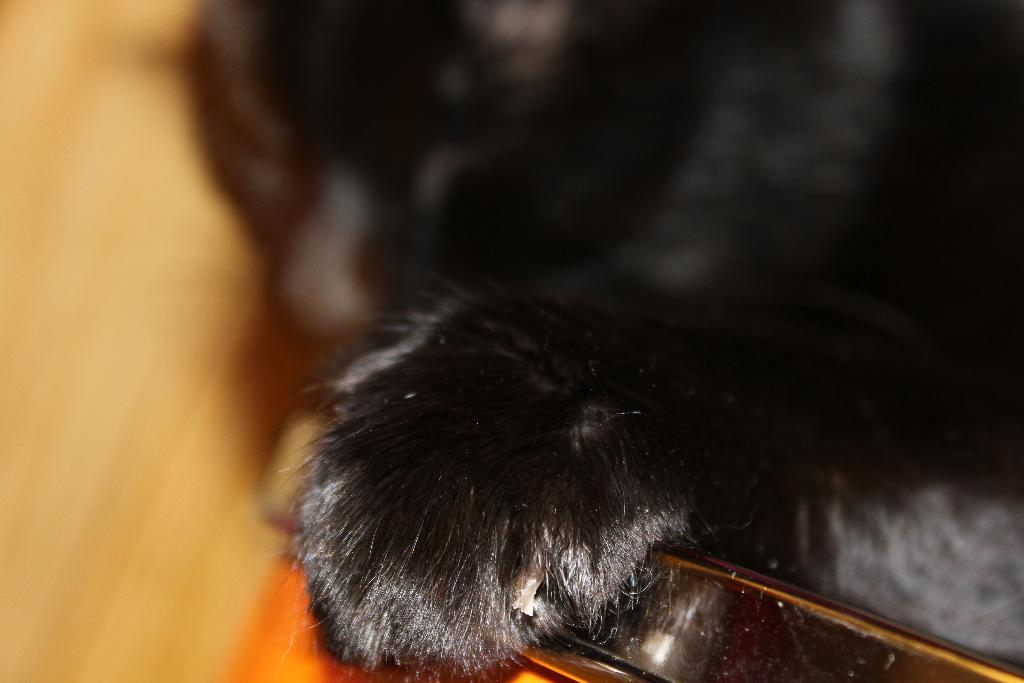What type of animal is present in the image? There is an animal in the image, but its specific type cannot be determined from the provided facts. What type of furniture is in the image? There is a chair in the image. How does the animal help to regulate the temperature in the image? There is no information provided about the animal's ability to regulate temperature, nor is there any indication of temperature regulation in the image. 